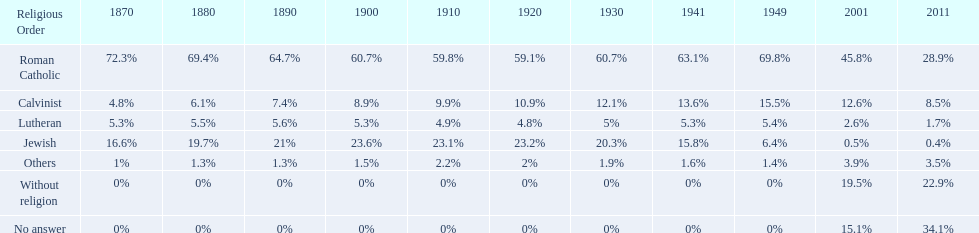What is the largest religious denomination in budapest? Roman Catholic. 